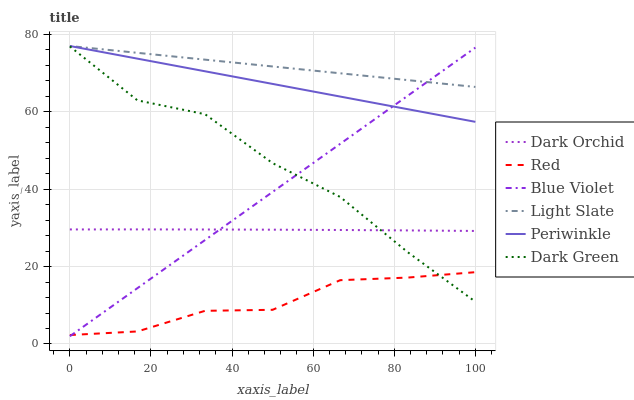Does Red have the minimum area under the curve?
Answer yes or no. Yes. Does Light Slate have the maximum area under the curve?
Answer yes or no. Yes. Does Dark Orchid have the minimum area under the curve?
Answer yes or no. No. Does Dark Orchid have the maximum area under the curve?
Answer yes or no. No. Is Blue Violet the smoothest?
Answer yes or no. Yes. Is Dark Green the roughest?
Answer yes or no. Yes. Is Dark Orchid the smoothest?
Answer yes or no. No. Is Dark Orchid the roughest?
Answer yes or no. No. Does Dark Orchid have the lowest value?
Answer yes or no. No. Does Periwinkle have the highest value?
Answer yes or no. Yes. Does Dark Orchid have the highest value?
Answer yes or no. No. Is Dark Orchid less than Light Slate?
Answer yes or no. Yes. Is Periwinkle greater than Dark Green?
Answer yes or no. Yes. Does Dark Orchid intersect Light Slate?
Answer yes or no. No. 